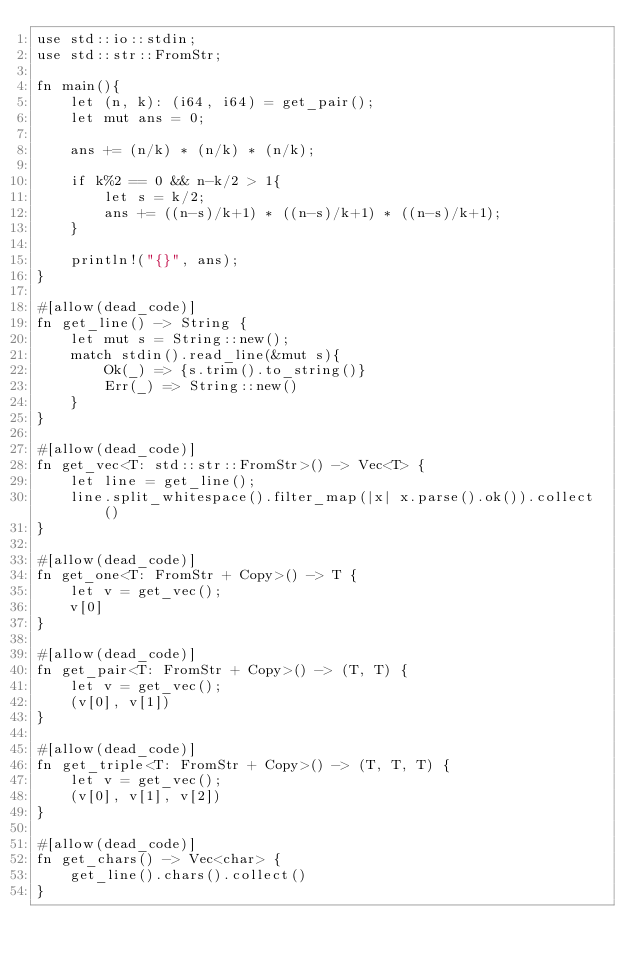<code> <loc_0><loc_0><loc_500><loc_500><_Rust_>use std::io::stdin;
use std::str::FromStr;

fn main(){
    let (n, k): (i64, i64) = get_pair();
    let mut ans = 0;

    ans += (n/k) * (n/k) * (n/k);

    if k%2 == 0 && n-k/2 > 1{
        let s = k/2;
        ans += ((n-s)/k+1) * ((n-s)/k+1) * ((n-s)/k+1);
    }

    println!("{}", ans);
}

#[allow(dead_code)]
fn get_line() -> String {
    let mut s = String::new();
    match stdin().read_line(&mut s){
        Ok(_) => {s.trim().to_string()}
        Err(_) => String::new()
    }
}

#[allow(dead_code)]
fn get_vec<T: std::str::FromStr>() -> Vec<T> {
    let line = get_line();
    line.split_whitespace().filter_map(|x| x.parse().ok()).collect()
}

#[allow(dead_code)]
fn get_one<T: FromStr + Copy>() -> T {
    let v = get_vec();
    v[0]
}

#[allow(dead_code)]
fn get_pair<T: FromStr + Copy>() -> (T, T) {
    let v = get_vec();
    (v[0], v[1])
}

#[allow(dead_code)]
fn get_triple<T: FromStr + Copy>() -> (T, T, T) {
    let v = get_vec();
    (v[0], v[1], v[2])
}

#[allow(dead_code)]
fn get_chars() -> Vec<char> {
    get_line().chars().collect()
}
</code> 